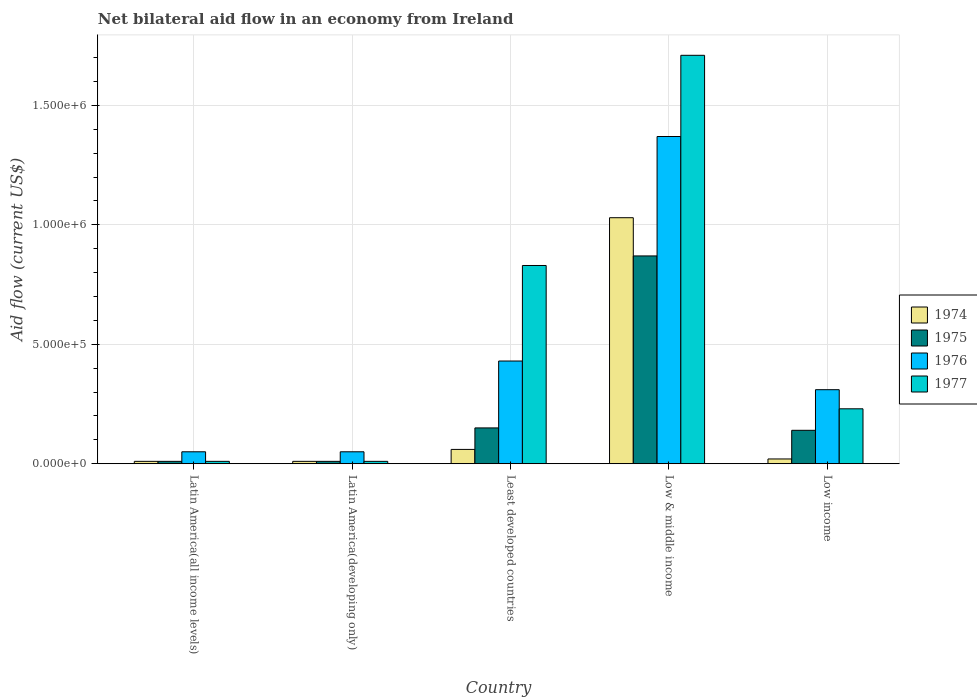How many different coloured bars are there?
Your answer should be compact. 4. How many groups of bars are there?
Ensure brevity in your answer.  5. Are the number of bars per tick equal to the number of legend labels?
Offer a terse response. Yes. How many bars are there on the 3rd tick from the left?
Provide a succinct answer. 4. What is the label of the 5th group of bars from the left?
Provide a short and direct response. Low income. In how many cases, is the number of bars for a given country not equal to the number of legend labels?
Offer a very short reply. 0. What is the net bilateral aid flow in 1975 in Latin America(developing only)?
Provide a short and direct response. 10000. Across all countries, what is the maximum net bilateral aid flow in 1977?
Your answer should be compact. 1.71e+06. Across all countries, what is the minimum net bilateral aid flow in 1977?
Offer a terse response. 10000. In which country was the net bilateral aid flow in 1977 minimum?
Your answer should be compact. Latin America(all income levels). What is the total net bilateral aid flow in 1976 in the graph?
Provide a short and direct response. 2.21e+06. What is the difference between the net bilateral aid flow in 1976 in Latin America(all income levels) and that in Least developed countries?
Keep it short and to the point. -3.80e+05. What is the difference between the net bilateral aid flow in 1975 in Latin America(developing only) and the net bilateral aid flow in 1974 in Low & middle income?
Offer a very short reply. -1.02e+06. What is the average net bilateral aid flow in 1975 per country?
Make the answer very short. 2.36e+05. In how many countries, is the net bilateral aid flow in 1975 greater than 700000 US$?
Give a very brief answer. 1. What is the ratio of the net bilateral aid flow in 1975 in Least developed countries to that in Low income?
Your response must be concise. 1.07. Is the net bilateral aid flow in 1975 in Low & middle income less than that in Low income?
Keep it short and to the point. No. Is the difference between the net bilateral aid flow in 1976 in Least developed countries and Low income greater than the difference between the net bilateral aid flow in 1974 in Least developed countries and Low income?
Your answer should be compact. Yes. What is the difference between the highest and the second highest net bilateral aid flow in 1975?
Your answer should be very brief. 7.30e+05. What is the difference between the highest and the lowest net bilateral aid flow in 1976?
Give a very brief answer. 1.32e+06. In how many countries, is the net bilateral aid flow in 1977 greater than the average net bilateral aid flow in 1977 taken over all countries?
Ensure brevity in your answer.  2. Is it the case that in every country, the sum of the net bilateral aid flow in 1976 and net bilateral aid flow in 1974 is greater than the sum of net bilateral aid flow in 1977 and net bilateral aid flow in 1975?
Offer a very short reply. No. What does the 2nd bar from the left in Low & middle income represents?
Make the answer very short. 1975. What does the 1st bar from the right in Latin America(developing only) represents?
Your response must be concise. 1977. Does the graph contain any zero values?
Offer a terse response. No. Does the graph contain grids?
Keep it short and to the point. Yes. Where does the legend appear in the graph?
Give a very brief answer. Center right. How many legend labels are there?
Keep it short and to the point. 4. What is the title of the graph?
Your answer should be very brief. Net bilateral aid flow in an economy from Ireland. What is the label or title of the X-axis?
Offer a terse response. Country. What is the label or title of the Y-axis?
Make the answer very short. Aid flow (current US$). What is the Aid flow (current US$) in 1975 in Latin America(all income levels)?
Keep it short and to the point. 10000. What is the Aid flow (current US$) in 1977 in Latin America(all income levels)?
Provide a short and direct response. 10000. What is the Aid flow (current US$) of 1976 in Latin America(developing only)?
Ensure brevity in your answer.  5.00e+04. What is the Aid flow (current US$) in 1976 in Least developed countries?
Keep it short and to the point. 4.30e+05. What is the Aid flow (current US$) of 1977 in Least developed countries?
Make the answer very short. 8.30e+05. What is the Aid flow (current US$) in 1974 in Low & middle income?
Your response must be concise. 1.03e+06. What is the Aid flow (current US$) of 1975 in Low & middle income?
Provide a succinct answer. 8.70e+05. What is the Aid flow (current US$) of 1976 in Low & middle income?
Your response must be concise. 1.37e+06. What is the Aid flow (current US$) in 1977 in Low & middle income?
Make the answer very short. 1.71e+06. What is the Aid flow (current US$) of 1974 in Low income?
Your answer should be compact. 2.00e+04. What is the Aid flow (current US$) in 1976 in Low income?
Provide a short and direct response. 3.10e+05. Across all countries, what is the maximum Aid flow (current US$) of 1974?
Provide a succinct answer. 1.03e+06. Across all countries, what is the maximum Aid flow (current US$) in 1975?
Your response must be concise. 8.70e+05. Across all countries, what is the maximum Aid flow (current US$) in 1976?
Make the answer very short. 1.37e+06. Across all countries, what is the maximum Aid flow (current US$) in 1977?
Your answer should be very brief. 1.71e+06. Across all countries, what is the minimum Aid flow (current US$) in 1975?
Your answer should be very brief. 10000. What is the total Aid flow (current US$) in 1974 in the graph?
Provide a succinct answer. 1.13e+06. What is the total Aid flow (current US$) of 1975 in the graph?
Your answer should be very brief. 1.18e+06. What is the total Aid flow (current US$) in 1976 in the graph?
Give a very brief answer. 2.21e+06. What is the total Aid flow (current US$) in 1977 in the graph?
Your answer should be very brief. 2.79e+06. What is the difference between the Aid flow (current US$) in 1974 in Latin America(all income levels) and that in Latin America(developing only)?
Your response must be concise. 0. What is the difference between the Aid flow (current US$) of 1975 in Latin America(all income levels) and that in Latin America(developing only)?
Provide a short and direct response. 0. What is the difference between the Aid flow (current US$) in 1976 in Latin America(all income levels) and that in Least developed countries?
Keep it short and to the point. -3.80e+05. What is the difference between the Aid flow (current US$) of 1977 in Latin America(all income levels) and that in Least developed countries?
Make the answer very short. -8.20e+05. What is the difference between the Aid flow (current US$) in 1974 in Latin America(all income levels) and that in Low & middle income?
Give a very brief answer. -1.02e+06. What is the difference between the Aid flow (current US$) of 1975 in Latin America(all income levels) and that in Low & middle income?
Provide a succinct answer. -8.60e+05. What is the difference between the Aid flow (current US$) in 1976 in Latin America(all income levels) and that in Low & middle income?
Your answer should be very brief. -1.32e+06. What is the difference between the Aid flow (current US$) of 1977 in Latin America(all income levels) and that in Low & middle income?
Your response must be concise. -1.70e+06. What is the difference between the Aid flow (current US$) of 1974 in Latin America(all income levels) and that in Low income?
Give a very brief answer. -10000. What is the difference between the Aid flow (current US$) in 1977 in Latin America(all income levels) and that in Low income?
Provide a short and direct response. -2.20e+05. What is the difference between the Aid flow (current US$) in 1976 in Latin America(developing only) and that in Least developed countries?
Your answer should be compact. -3.80e+05. What is the difference between the Aid flow (current US$) of 1977 in Latin America(developing only) and that in Least developed countries?
Keep it short and to the point. -8.20e+05. What is the difference between the Aid flow (current US$) in 1974 in Latin America(developing only) and that in Low & middle income?
Provide a short and direct response. -1.02e+06. What is the difference between the Aid flow (current US$) in 1975 in Latin America(developing only) and that in Low & middle income?
Provide a succinct answer. -8.60e+05. What is the difference between the Aid flow (current US$) in 1976 in Latin America(developing only) and that in Low & middle income?
Offer a terse response. -1.32e+06. What is the difference between the Aid flow (current US$) in 1977 in Latin America(developing only) and that in Low & middle income?
Provide a succinct answer. -1.70e+06. What is the difference between the Aid flow (current US$) in 1974 in Latin America(developing only) and that in Low income?
Your answer should be very brief. -10000. What is the difference between the Aid flow (current US$) in 1974 in Least developed countries and that in Low & middle income?
Your answer should be compact. -9.70e+05. What is the difference between the Aid flow (current US$) in 1975 in Least developed countries and that in Low & middle income?
Provide a short and direct response. -7.20e+05. What is the difference between the Aid flow (current US$) in 1976 in Least developed countries and that in Low & middle income?
Offer a terse response. -9.40e+05. What is the difference between the Aid flow (current US$) in 1977 in Least developed countries and that in Low & middle income?
Make the answer very short. -8.80e+05. What is the difference between the Aid flow (current US$) in 1974 in Least developed countries and that in Low income?
Provide a short and direct response. 4.00e+04. What is the difference between the Aid flow (current US$) of 1975 in Least developed countries and that in Low income?
Give a very brief answer. 10000. What is the difference between the Aid flow (current US$) in 1976 in Least developed countries and that in Low income?
Make the answer very short. 1.20e+05. What is the difference between the Aid flow (current US$) in 1977 in Least developed countries and that in Low income?
Keep it short and to the point. 6.00e+05. What is the difference between the Aid flow (current US$) of 1974 in Low & middle income and that in Low income?
Your answer should be compact. 1.01e+06. What is the difference between the Aid flow (current US$) of 1975 in Low & middle income and that in Low income?
Provide a succinct answer. 7.30e+05. What is the difference between the Aid flow (current US$) of 1976 in Low & middle income and that in Low income?
Your response must be concise. 1.06e+06. What is the difference between the Aid flow (current US$) of 1977 in Low & middle income and that in Low income?
Give a very brief answer. 1.48e+06. What is the difference between the Aid flow (current US$) in 1974 in Latin America(all income levels) and the Aid flow (current US$) in 1975 in Latin America(developing only)?
Your answer should be very brief. 0. What is the difference between the Aid flow (current US$) of 1974 in Latin America(all income levels) and the Aid flow (current US$) of 1976 in Latin America(developing only)?
Your answer should be compact. -4.00e+04. What is the difference between the Aid flow (current US$) in 1974 in Latin America(all income levels) and the Aid flow (current US$) in 1975 in Least developed countries?
Keep it short and to the point. -1.40e+05. What is the difference between the Aid flow (current US$) in 1974 in Latin America(all income levels) and the Aid flow (current US$) in 1976 in Least developed countries?
Offer a terse response. -4.20e+05. What is the difference between the Aid flow (current US$) in 1974 in Latin America(all income levels) and the Aid flow (current US$) in 1977 in Least developed countries?
Your response must be concise. -8.20e+05. What is the difference between the Aid flow (current US$) of 1975 in Latin America(all income levels) and the Aid flow (current US$) of 1976 in Least developed countries?
Your answer should be compact. -4.20e+05. What is the difference between the Aid flow (current US$) of 1975 in Latin America(all income levels) and the Aid flow (current US$) of 1977 in Least developed countries?
Provide a succinct answer. -8.20e+05. What is the difference between the Aid flow (current US$) of 1976 in Latin America(all income levels) and the Aid flow (current US$) of 1977 in Least developed countries?
Offer a terse response. -7.80e+05. What is the difference between the Aid flow (current US$) of 1974 in Latin America(all income levels) and the Aid flow (current US$) of 1975 in Low & middle income?
Your answer should be very brief. -8.60e+05. What is the difference between the Aid flow (current US$) in 1974 in Latin America(all income levels) and the Aid flow (current US$) in 1976 in Low & middle income?
Make the answer very short. -1.36e+06. What is the difference between the Aid flow (current US$) of 1974 in Latin America(all income levels) and the Aid flow (current US$) of 1977 in Low & middle income?
Your answer should be very brief. -1.70e+06. What is the difference between the Aid flow (current US$) in 1975 in Latin America(all income levels) and the Aid flow (current US$) in 1976 in Low & middle income?
Provide a short and direct response. -1.36e+06. What is the difference between the Aid flow (current US$) of 1975 in Latin America(all income levels) and the Aid flow (current US$) of 1977 in Low & middle income?
Your answer should be very brief. -1.70e+06. What is the difference between the Aid flow (current US$) of 1976 in Latin America(all income levels) and the Aid flow (current US$) of 1977 in Low & middle income?
Offer a terse response. -1.66e+06. What is the difference between the Aid flow (current US$) of 1975 in Latin America(all income levels) and the Aid flow (current US$) of 1977 in Low income?
Make the answer very short. -2.20e+05. What is the difference between the Aid flow (current US$) of 1974 in Latin America(developing only) and the Aid flow (current US$) of 1975 in Least developed countries?
Make the answer very short. -1.40e+05. What is the difference between the Aid flow (current US$) in 1974 in Latin America(developing only) and the Aid flow (current US$) in 1976 in Least developed countries?
Your answer should be very brief. -4.20e+05. What is the difference between the Aid flow (current US$) in 1974 in Latin America(developing only) and the Aid flow (current US$) in 1977 in Least developed countries?
Your response must be concise. -8.20e+05. What is the difference between the Aid flow (current US$) in 1975 in Latin America(developing only) and the Aid flow (current US$) in 1976 in Least developed countries?
Your answer should be very brief. -4.20e+05. What is the difference between the Aid flow (current US$) of 1975 in Latin America(developing only) and the Aid flow (current US$) of 1977 in Least developed countries?
Your response must be concise. -8.20e+05. What is the difference between the Aid flow (current US$) of 1976 in Latin America(developing only) and the Aid flow (current US$) of 1977 in Least developed countries?
Your response must be concise. -7.80e+05. What is the difference between the Aid flow (current US$) of 1974 in Latin America(developing only) and the Aid flow (current US$) of 1975 in Low & middle income?
Offer a very short reply. -8.60e+05. What is the difference between the Aid flow (current US$) in 1974 in Latin America(developing only) and the Aid flow (current US$) in 1976 in Low & middle income?
Provide a succinct answer. -1.36e+06. What is the difference between the Aid flow (current US$) of 1974 in Latin America(developing only) and the Aid flow (current US$) of 1977 in Low & middle income?
Provide a short and direct response. -1.70e+06. What is the difference between the Aid flow (current US$) in 1975 in Latin America(developing only) and the Aid flow (current US$) in 1976 in Low & middle income?
Provide a succinct answer. -1.36e+06. What is the difference between the Aid flow (current US$) in 1975 in Latin America(developing only) and the Aid flow (current US$) in 1977 in Low & middle income?
Keep it short and to the point. -1.70e+06. What is the difference between the Aid flow (current US$) in 1976 in Latin America(developing only) and the Aid flow (current US$) in 1977 in Low & middle income?
Offer a terse response. -1.66e+06. What is the difference between the Aid flow (current US$) of 1974 in Latin America(developing only) and the Aid flow (current US$) of 1975 in Low income?
Your answer should be very brief. -1.30e+05. What is the difference between the Aid flow (current US$) in 1974 in Latin America(developing only) and the Aid flow (current US$) in 1977 in Low income?
Offer a terse response. -2.20e+05. What is the difference between the Aid flow (current US$) in 1975 in Latin America(developing only) and the Aid flow (current US$) in 1977 in Low income?
Offer a terse response. -2.20e+05. What is the difference between the Aid flow (current US$) in 1974 in Least developed countries and the Aid flow (current US$) in 1975 in Low & middle income?
Keep it short and to the point. -8.10e+05. What is the difference between the Aid flow (current US$) in 1974 in Least developed countries and the Aid flow (current US$) in 1976 in Low & middle income?
Your answer should be compact. -1.31e+06. What is the difference between the Aid flow (current US$) in 1974 in Least developed countries and the Aid flow (current US$) in 1977 in Low & middle income?
Offer a terse response. -1.65e+06. What is the difference between the Aid flow (current US$) of 1975 in Least developed countries and the Aid flow (current US$) of 1976 in Low & middle income?
Your response must be concise. -1.22e+06. What is the difference between the Aid flow (current US$) in 1975 in Least developed countries and the Aid flow (current US$) in 1977 in Low & middle income?
Your response must be concise. -1.56e+06. What is the difference between the Aid flow (current US$) in 1976 in Least developed countries and the Aid flow (current US$) in 1977 in Low & middle income?
Give a very brief answer. -1.28e+06. What is the difference between the Aid flow (current US$) in 1974 in Least developed countries and the Aid flow (current US$) in 1975 in Low income?
Your response must be concise. -8.00e+04. What is the difference between the Aid flow (current US$) of 1974 in Least developed countries and the Aid flow (current US$) of 1977 in Low income?
Provide a short and direct response. -1.70e+05. What is the difference between the Aid flow (current US$) of 1975 in Least developed countries and the Aid flow (current US$) of 1977 in Low income?
Ensure brevity in your answer.  -8.00e+04. What is the difference between the Aid flow (current US$) in 1976 in Least developed countries and the Aid flow (current US$) in 1977 in Low income?
Offer a terse response. 2.00e+05. What is the difference between the Aid flow (current US$) of 1974 in Low & middle income and the Aid flow (current US$) of 1975 in Low income?
Your answer should be compact. 8.90e+05. What is the difference between the Aid flow (current US$) of 1974 in Low & middle income and the Aid flow (current US$) of 1976 in Low income?
Ensure brevity in your answer.  7.20e+05. What is the difference between the Aid flow (current US$) in 1975 in Low & middle income and the Aid flow (current US$) in 1976 in Low income?
Your answer should be very brief. 5.60e+05. What is the difference between the Aid flow (current US$) of 1975 in Low & middle income and the Aid flow (current US$) of 1977 in Low income?
Your answer should be very brief. 6.40e+05. What is the difference between the Aid flow (current US$) in 1976 in Low & middle income and the Aid flow (current US$) in 1977 in Low income?
Your response must be concise. 1.14e+06. What is the average Aid flow (current US$) of 1974 per country?
Ensure brevity in your answer.  2.26e+05. What is the average Aid flow (current US$) of 1975 per country?
Give a very brief answer. 2.36e+05. What is the average Aid flow (current US$) of 1976 per country?
Your answer should be compact. 4.42e+05. What is the average Aid flow (current US$) in 1977 per country?
Your response must be concise. 5.58e+05. What is the difference between the Aid flow (current US$) of 1974 and Aid flow (current US$) of 1975 in Latin America(all income levels)?
Keep it short and to the point. 0. What is the difference between the Aid flow (current US$) in 1975 and Aid flow (current US$) in 1977 in Latin America(all income levels)?
Your response must be concise. 0. What is the difference between the Aid flow (current US$) in 1976 and Aid flow (current US$) in 1977 in Latin America(all income levels)?
Provide a succinct answer. 4.00e+04. What is the difference between the Aid flow (current US$) of 1974 and Aid flow (current US$) of 1975 in Latin America(developing only)?
Your answer should be compact. 0. What is the difference between the Aid flow (current US$) of 1974 and Aid flow (current US$) of 1976 in Latin America(developing only)?
Your answer should be compact. -4.00e+04. What is the difference between the Aid flow (current US$) of 1975 and Aid flow (current US$) of 1976 in Latin America(developing only)?
Keep it short and to the point. -4.00e+04. What is the difference between the Aid flow (current US$) in 1975 and Aid flow (current US$) in 1977 in Latin America(developing only)?
Provide a succinct answer. 0. What is the difference between the Aid flow (current US$) of 1974 and Aid flow (current US$) of 1976 in Least developed countries?
Keep it short and to the point. -3.70e+05. What is the difference between the Aid flow (current US$) of 1974 and Aid flow (current US$) of 1977 in Least developed countries?
Make the answer very short. -7.70e+05. What is the difference between the Aid flow (current US$) in 1975 and Aid flow (current US$) in 1976 in Least developed countries?
Offer a very short reply. -2.80e+05. What is the difference between the Aid flow (current US$) in 1975 and Aid flow (current US$) in 1977 in Least developed countries?
Your response must be concise. -6.80e+05. What is the difference between the Aid flow (current US$) in 1976 and Aid flow (current US$) in 1977 in Least developed countries?
Your answer should be compact. -4.00e+05. What is the difference between the Aid flow (current US$) of 1974 and Aid flow (current US$) of 1976 in Low & middle income?
Your response must be concise. -3.40e+05. What is the difference between the Aid flow (current US$) of 1974 and Aid flow (current US$) of 1977 in Low & middle income?
Your answer should be compact. -6.80e+05. What is the difference between the Aid flow (current US$) of 1975 and Aid flow (current US$) of 1976 in Low & middle income?
Ensure brevity in your answer.  -5.00e+05. What is the difference between the Aid flow (current US$) of 1975 and Aid flow (current US$) of 1977 in Low & middle income?
Your answer should be very brief. -8.40e+05. What is the difference between the Aid flow (current US$) of 1976 and Aid flow (current US$) of 1977 in Low & middle income?
Your answer should be compact. -3.40e+05. What is the difference between the Aid flow (current US$) of 1974 and Aid flow (current US$) of 1975 in Low income?
Offer a terse response. -1.20e+05. What is the difference between the Aid flow (current US$) in 1975 and Aid flow (current US$) in 1976 in Low income?
Ensure brevity in your answer.  -1.70e+05. What is the difference between the Aid flow (current US$) of 1975 and Aid flow (current US$) of 1977 in Low income?
Ensure brevity in your answer.  -9.00e+04. What is the ratio of the Aid flow (current US$) in 1975 in Latin America(all income levels) to that in Latin America(developing only)?
Provide a short and direct response. 1. What is the ratio of the Aid flow (current US$) in 1977 in Latin America(all income levels) to that in Latin America(developing only)?
Your response must be concise. 1. What is the ratio of the Aid flow (current US$) in 1975 in Latin America(all income levels) to that in Least developed countries?
Keep it short and to the point. 0.07. What is the ratio of the Aid flow (current US$) of 1976 in Latin America(all income levels) to that in Least developed countries?
Ensure brevity in your answer.  0.12. What is the ratio of the Aid flow (current US$) in 1977 in Latin America(all income levels) to that in Least developed countries?
Offer a terse response. 0.01. What is the ratio of the Aid flow (current US$) of 1974 in Latin America(all income levels) to that in Low & middle income?
Give a very brief answer. 0.01. What is the ratio of the Aid flow (current US$) in 1975 in Latin America(all income levels) to that in Low & middle income?
Offer a terse response. 0.01. What is the ratio of the Aid flow (current US$) in 1976 in Latin America(all income levels) to that in Low & middle income?
Your response must be concise. 0.04. What is the ratio of the Aid flow (current US$) in 1977 in Latin America(all income levels) to that in Low & middle income?
Offer a very short reply. 0.01. What is the ratio of the Aid flow (current US$) of 1974 in Latin America(all income levels) to that in Low income?
Make the answer very short. 0.5. What is the ratio of the Aid flow (current US$) in 1975 in Latin America(all income levels) to that in Low income?
Offer a very short reply. 0.07. What is the ratio of the Aid flow (current US$) of 1976 in Latin America(all income levels) to that in Low income?
Make the answer very short. 0.16. What is the ratio of the Aid flow (current US$) of 1977 in Latin America(all income levels) to that in Low income?
Ensure brevity in your answer.  0.04. What is the ratio of the Aid flow (current US$) of 1975 in Latin America(developing only) to that in Least developed countries?
Give a very brief answer. 0.07. What is the ratio of the Aid flow (current US$) of 1976 in Latin America(developing only) to that in Least developed countries?
Your answer should be very brief. 0.12. What is the ratio of the Aid flow (current US$) of 1977 in Latin America(developing only) to that in Least developed countries?
Your response must be concise. 0.01. What is the ratio of the Aid flow (current US$) of 1974 in Latin America(developing only) to that in Low & middle income?
Give a very brief answer. 0.01. What is the ratio of the Aid flow (current US$) in 1975 in Latin America(developing only) to that in Low & middle income?
Your response must be concise. 0.01. What is the ratio of the Aid flow (current US$) in 1976 in Latin America(developing only) to that in Low & middle income?
Make the answer very short. 0.04. What is the ratio of the Aid flow (current US$) in 1977 in Latin America(developing only) to that in Low & middle income?
Your answer should be very brief. 0.01. What is the ratio of the Aid flow (current US$) of 1974 in Latin America(developing only) to that in Low income?
Your response must be concise. 0.5. What is the ratio of the Aid flow (current US$) in 1975 in Latin America(developing only) to that in Low income?
Your answer should be very brief. 0.07. What is the ratio of the Aid flow (current US$) in 1976 in Latin America(developing only) to that in Low income?
Provide a short and direct response. 0.16. What is the ratio of the Aid flow (current US$) in 1977 in Latin America(developing only) to that in Low income?
Your response must be concise. 0.04. What is the ratio of the Aid flow (current US$) in 1974 in Least developed countries to that in Low & middle income?
Give a very brief answer. 0.06. What is the ratio of the Aid flow (current US$) in 1975 in Least developed countries to that in Low & middle income?
Offer a very short reply. 0.17. What is the ratio of the Aid flow (current US$) in 1976 in Least developed countries to that in Low & middle income?
Your answer should be compact. 0.31. What is the ratio of the Aid flow (current US$) of 1977 in Least developed countries to that in Low & middle income?
Your answer should be compact. 0.49. What is the ratio of the Aid flow (current US$) of 1975 in Least developed countries to that in Low income?
Your answer should be very brief. 1.07. What is the ratio of the Aid flow (current US$) in 1976 in Least developed countries to that in Low income?
Ensure brevity in your answer.  1.39. What is the ratio of the Aid flow (current US$) of 1977 in Least developed countries to that in Low income?
Offer a very short reply. 3.61. What is the ratio of the Aid flow (current US$) in 1974 in Low & middle income to that in Low income?
Provide a short and direct response. 51.5. What is the ratio of the Aid flow (current US$) of 1975 in Low & middle income to that in Low income?
Give a very brief answer. 6.21. What is the ratio of the Aid flow (current US$) in 1976 in Low & middle income to that in Low income?
Your response must be concise. 4.42. What is the ratio of the Aid flow (current US$) of 1977 in Low & middle income to that in Low income?
Give a very brief answer. 7.43. What is the difference between the highest and the second highest Aid flow (current US$) of 1974?
Ensure brevity in your answer.  9.70e+05. What is the difference between the highest and the second highest Aid flow (current US$) in 1975?
Your response must be concise. 7.20e+05. What is the difference between the highest and the second highest Aid flow (current US$) in 1976?
Offer a very short reply. 9.40e+05. What is the difference between the highest and the second highest Aid flow (current US$) in 1977?
Keep it short and to the point. 8.80e+05. What is the difference between the highest and the lowest Aid flow (current US$) in 1974?
Make the answer very short. 1.02e+06. What is the difference between the highest and the lowest Aid flow (current US$) of 1975?
Your answer should be very brief. 8.60e+05. What is the difference between the highest and the lowest Aid flow (current US$) in 1976?
Offer a very short reply. 1.32e+06. What is the difference between the highest and the lowest Aid flow (current US$) of 1977?
Provide a succinct answer. 1.70e+06. 